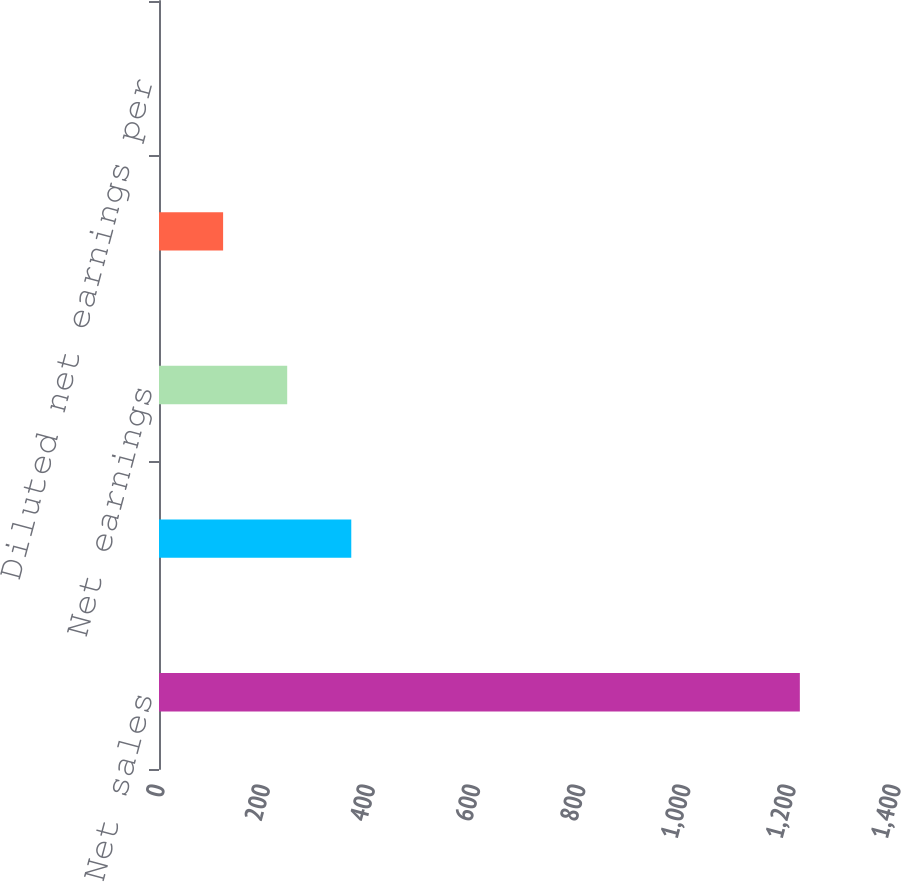Convert chart. <chart><loc_0><loc_0><loc_500><loc_500><bar_chart><fcel>Net sales<fcel>Gross profit<fcel>Net earnings<fcel>Basic net earnings per common<fcel>Diluted net earnings per<nl><fcel>1219<fcel>365.75<fcel>243.85<fcel>121.95<fcel>0.05<nl></chart> 